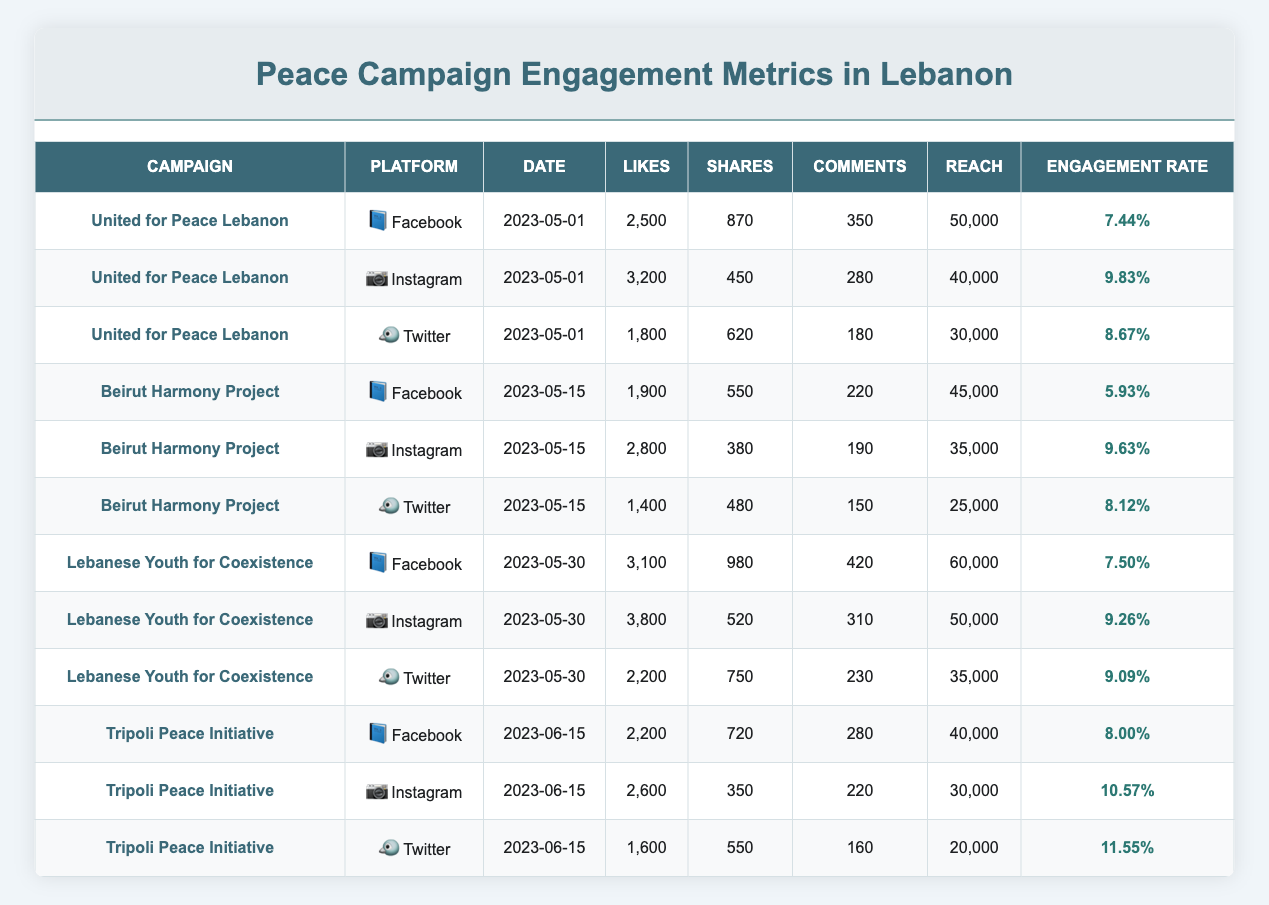What is the engagement rate for the "United for Peace Lebanon" campaign on Instagram? The engagement rate for this campaign on Instagram is mentioned in the table under the corresponding row. It reads 9.83%, which is clearly stated in the last column for that particular campaign and platform.
Answer: 9.83% Which campaign had the highest likes on Facebook? To determine the highest likes on Facebook, I look at the likes column for the rows where the platform is Facebook. The maximum number is 3100 for "Lebanese Youth for Coexistence."
Answer: Lebanese Youth for Coexistence What is the average engagement rate across all platforms for the "Beirut Harmony Project"? I first locate the engagement rates for all platforms under the "Beirut Harmony Project." These are 5.93%, 9.63%, and 8.12%. Next, I add these rates (5.93 + 9.63 + 8.12 = 23.68) and divide by the number of platforms (3) to get the average: 23.68 / 3 = 7.89%.
Answer: 7.89% Did the "Tripoli Peace Initiative" perform better in terms of engagement on Twitter than on Facebook? I check the engagement rates for "Tripoli Peace Initiative" on both platforms. The rate on Twitter is 11.55%, while on Facebook it is 8.00%. Since 11.55% is greater than 8.00%, I conclude that it performed better on Twitter.
Answer: Yes Which platform had the highest total reach for the "Lebanese Youth for Coexistence" campaign? I look at the reach column for all platforms of the "Lebanese Youth for Coexistence" campaign, which are 60,000 for Facebook, 50,000 for Instagram, and 35,000 for Twitter. The maximum value is 60,000 for Facebook.
Answer: Facebook 